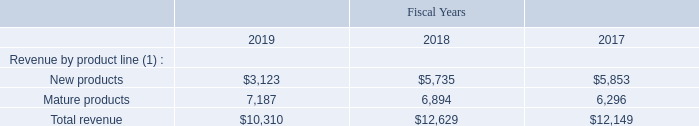NOTE 14-INFORMATION CONCERNING PRODUCT LINES, GEOGRAPHIC INFORMATION, ACCOUNTS RECEIVABLE AND REVENUE CONCENTRATION
The Company identifies its business segments based on business activities, management responsibility and geographic location. For all periods presented, the Company operated in a single reportable business segment.
The following is a breakdown of revenue by product family (in thousands):
(1) New products include all products manufactured on 180 nanometer or smaller semiconductor processes, eFPGA IP license, QuickAI and SensiML AI software as a service (SaaS) revenues. Mature products include all products produced on semiconductor processes larger than 180 nanometer.
What are the respective revenue from new products in 2018 and 2019?
Answer scale should be: thousand. $5,735, $3,123. What are the respective revenue from mature products in 2018 and 2019?
Answer scale should be: thousand. 6,894, 7,187. What are the respective total revenue in 2018 and 2019? 
Answer scale should be: thousand. $12,629, $10,310. What is the total revenue from new products in 2018 and 2019?
Answer scale should be: thousand.  ($5,735 + $3,123) 
Answer: 8858. What is the average revenue from mature products in 2018 and 2019?
Answer scale should be: thousand.  (6,894 + 7,187)/2 
Answer: 7040.5. What is the percentage change in total revenue between 2018 and 2019?
Answer scale should be: percent. (10,310 - 12,629)/12,629 
Answer: -18.36. 